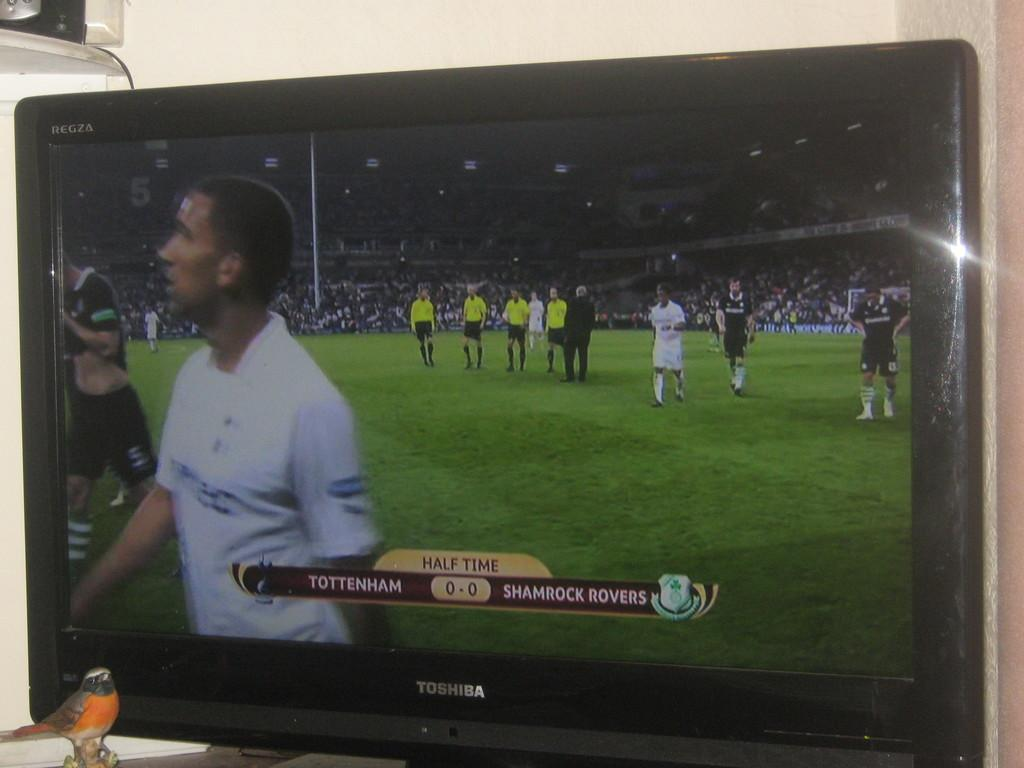<image>
Share a concise interpretation of the image provided. Toshiba television with Tottenham vs Shamrock Rovers at half time. 